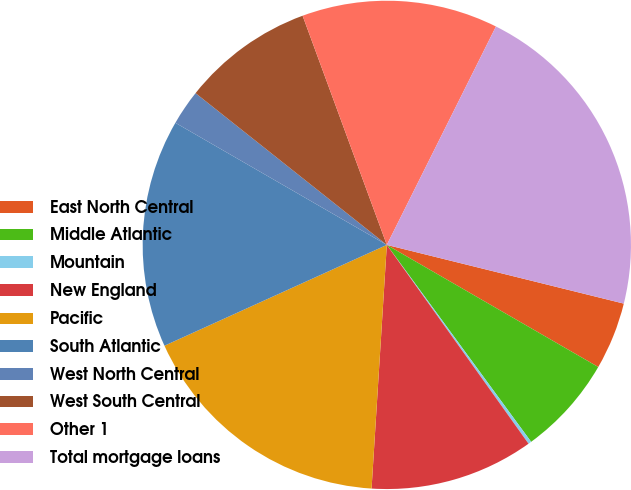<chart> <loc_0><loc_0><loc_500><loc_500><pie_chart><fcel>East North Central<fcel>Middle Atlantic<fcel>Mountain<fcel>New England<fcel>Pacific<fcel>South Atlantic<fcel>West North Central<fcel>West South Central<fcel>Other 1<fcel>Total mortgage loans<nl><fcel>4.47%<fcel>6.6%<fcel>0.21%<fcel>10.85%<fcel>17.23%<fcel>15.11%<fcel>2.34%<fcel>8.72%<fcel>12.98%<fcel>21.49%<nl></chart> 